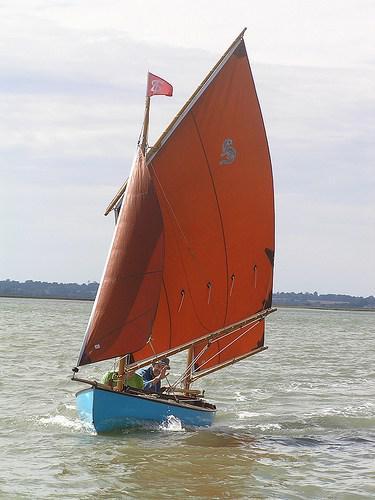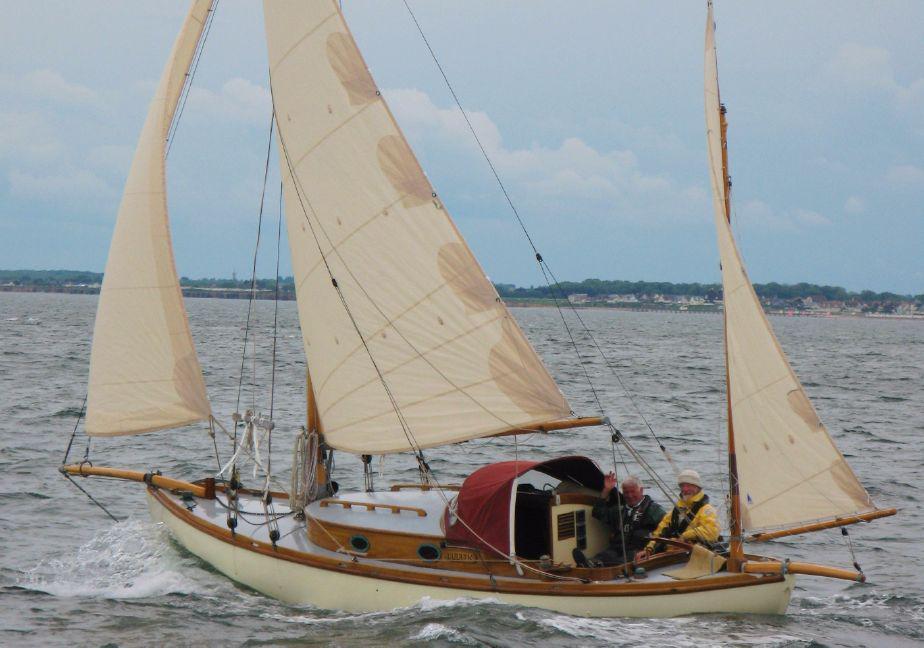The first image is the image on the left, the second image is the image on the right. Considering the images on both sides, is "The sailboats in the left and right images each have unfurled sails that are colored instead of white." valid? Answer yes or no. No. 